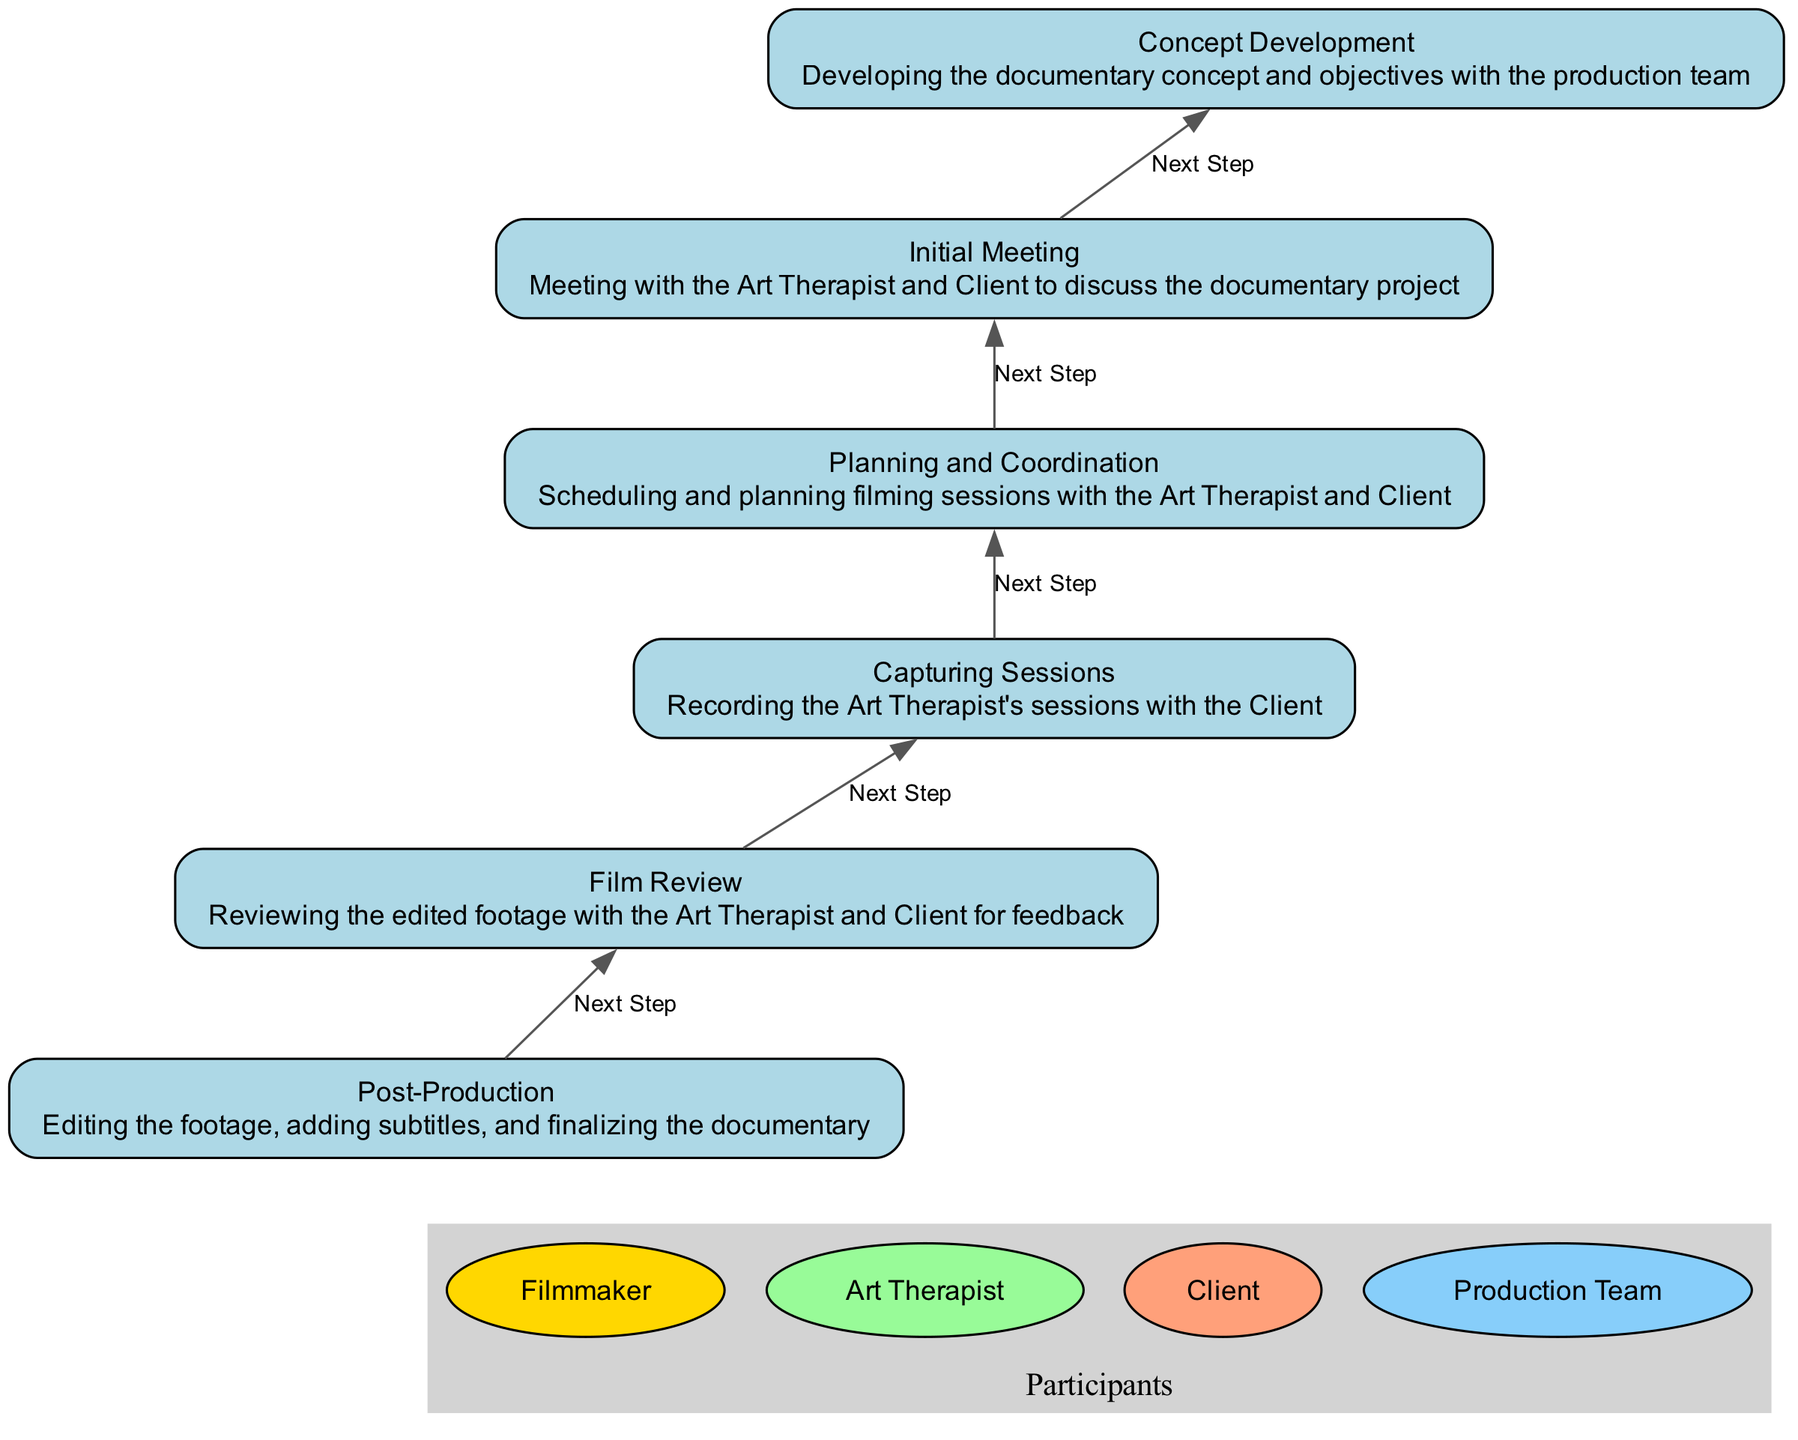What is the first step in the collaboration process? The first step is the "Initial Meeting," which is denoted as the bottom node in the diagram and serves as the starting point for the collaboration process.
Answer: Initial Meeting How many elements are present in the diagram? The diagram contains six elements as indicated by the nodes labeled from "Post-Production" to "Concept Development."
Answer: Six Which three participants are involved in the "Film Review"? The "Film Review" node connects the Art Therapist, Client, and Filmmaker, indicating their involvement in this step.
Answer: Art Therapist, Client, Filmmaker What is the last step in the instruction flow? The last step is "Post-Production," which is at the top of the flow chart and represents the finalization of the documentary.
Answer: Post-Production How does "Capturing Sessions" relate to "Planning and Coordination"? "Capturing Sessions" follows directly after "Planning and Coordination", indicating that capturing artwork occurs after planning has been established.
Answer: Capturing Sessions follows Planning and Coordination Which participant is not directly connected to "Concept Development"? The Client is not directly connected to the "Concept Development" node; this step only involves the Filmmaker and the Production Team.
Answer: Client What is the relationship between the "Film Review" and "Capturing Sessions"? The "Film Review" follows the "Capturing Sessions," implying that the review of footage occurs after the sessions have been recorded.
Answer: Film Review follows Capturing Sessions Which step involves the most participants? The "Film Review" step involves three participants: the Art Therapist, the Client, and the Filmmaker, which is the highest number of participants in any step.
Answer: Film Review How many steps are there between "Initial Meeting" and "Post-Production"? There are four steps between "Initial Meeting" and "Post-Production", which include "Planning and Coordination," "Capturing Sessions," "Film Review," and "Concept Development."
Answer: Four 